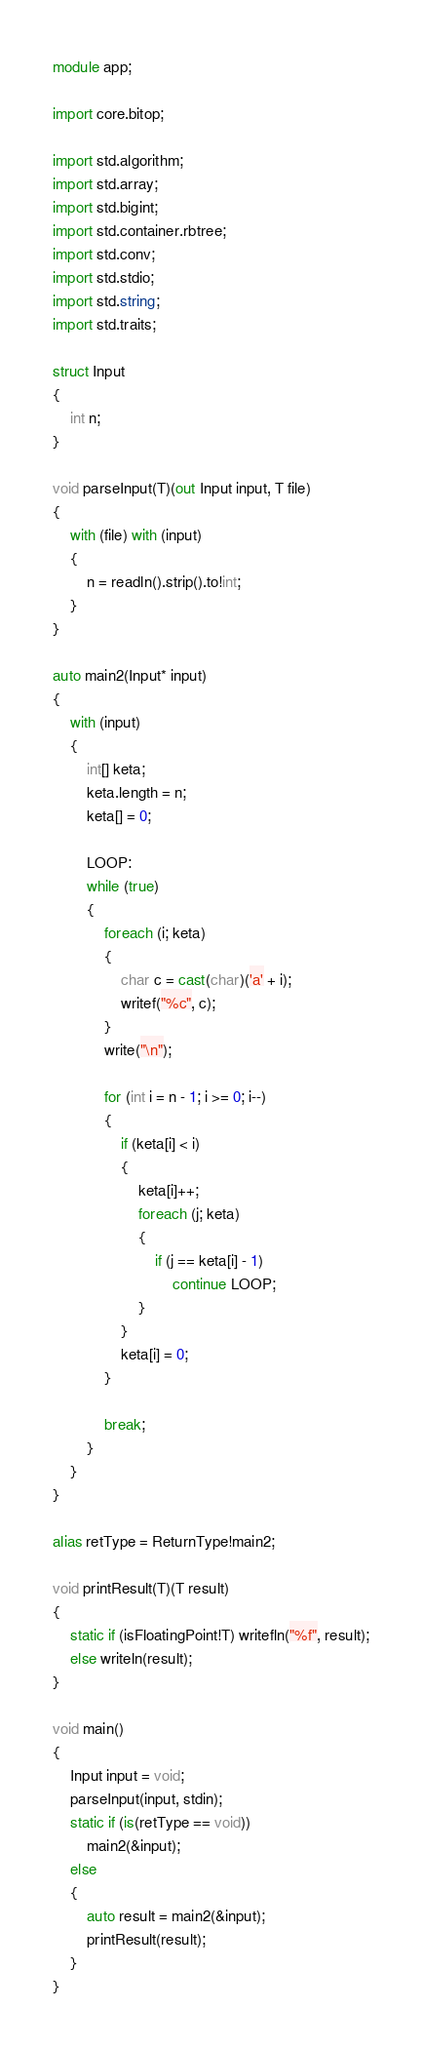<code> <loc_0><loc_0><loc_500><loc_500><_D_>module app;

import core.bitop;

import std.algorithm;
import std.array;
import std.bigint;
import std.container.rbtree;
import std.conv;
import std.stdio;
import std.string;
import std.traits;

struct Input
{
	int n;
}

void parseInput(T)(out Input input, T file)
{
	with (file) with (input)
	{
		n = readln().strip().to!int;
	}
}

auto main2(Input* input)
{
	with (input)
	{
		int[] keta;
        keta.length = n;
        keta[] = 0;

        LOOP:
        while (true)
        {
            foreach (i; keta)
            {
                char c = cast(char)('a' + i);
                writef("%c", c);
            }
            write("\n");

            for (int i = n - 1; i >= 0; i--)
            {
                if (keta[i] < i)
                {
                    keta[i]++;
                    foreach (j; keta)
                    {
                        if (j == keta[i] - 1)
                            continue LOOP;
                    }
                }
                keta[i] = 0;
            }

            break;
        }
	}
}

alias retType = ReturnType!main2;

void printResult(T)(T result)
{
	static if (isFloatingPoint!T) writefln("%f", result);
	else writeln(result);
}

void main()
{
	Input input = void;
	parseInput(input, stdin);
	static if (is(retType == void))
		main2(&input);
	else
	{
		auto result = main2(&input);
		printResult(result);
	}
}
</code> 